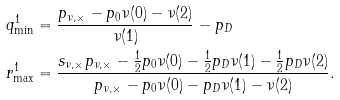Convert formula to latex. <formula><loc_0><loc_0><loc_500><loc_500>q ^ { 1 } _ { \min } & = \frac { p _ { \nu , \times } - p _ { 0 } \nu ( 0 ) - \nu ( 2 ) } { \nu ( 1 ) } - p _ { D } \\ r ^ { 1 } _ { \max } & = \frac { s _ { \nu , \times } p _ { \nu , \times } - \frac { 1 } { 2 } p _ { 0 } \nu ( 0 ) - \frac { 1 } { 2 } p _ { D } \nu ( 1 ) - \frac { 1 } { 2 } p _ { D } \nu ( 2 ) } { p _ { \nu , \times } - p _ { 0 } \nu ( 0 ) - p _ { D } \nu ( 1 ) - \nu ( 2 ) } .</formula> 